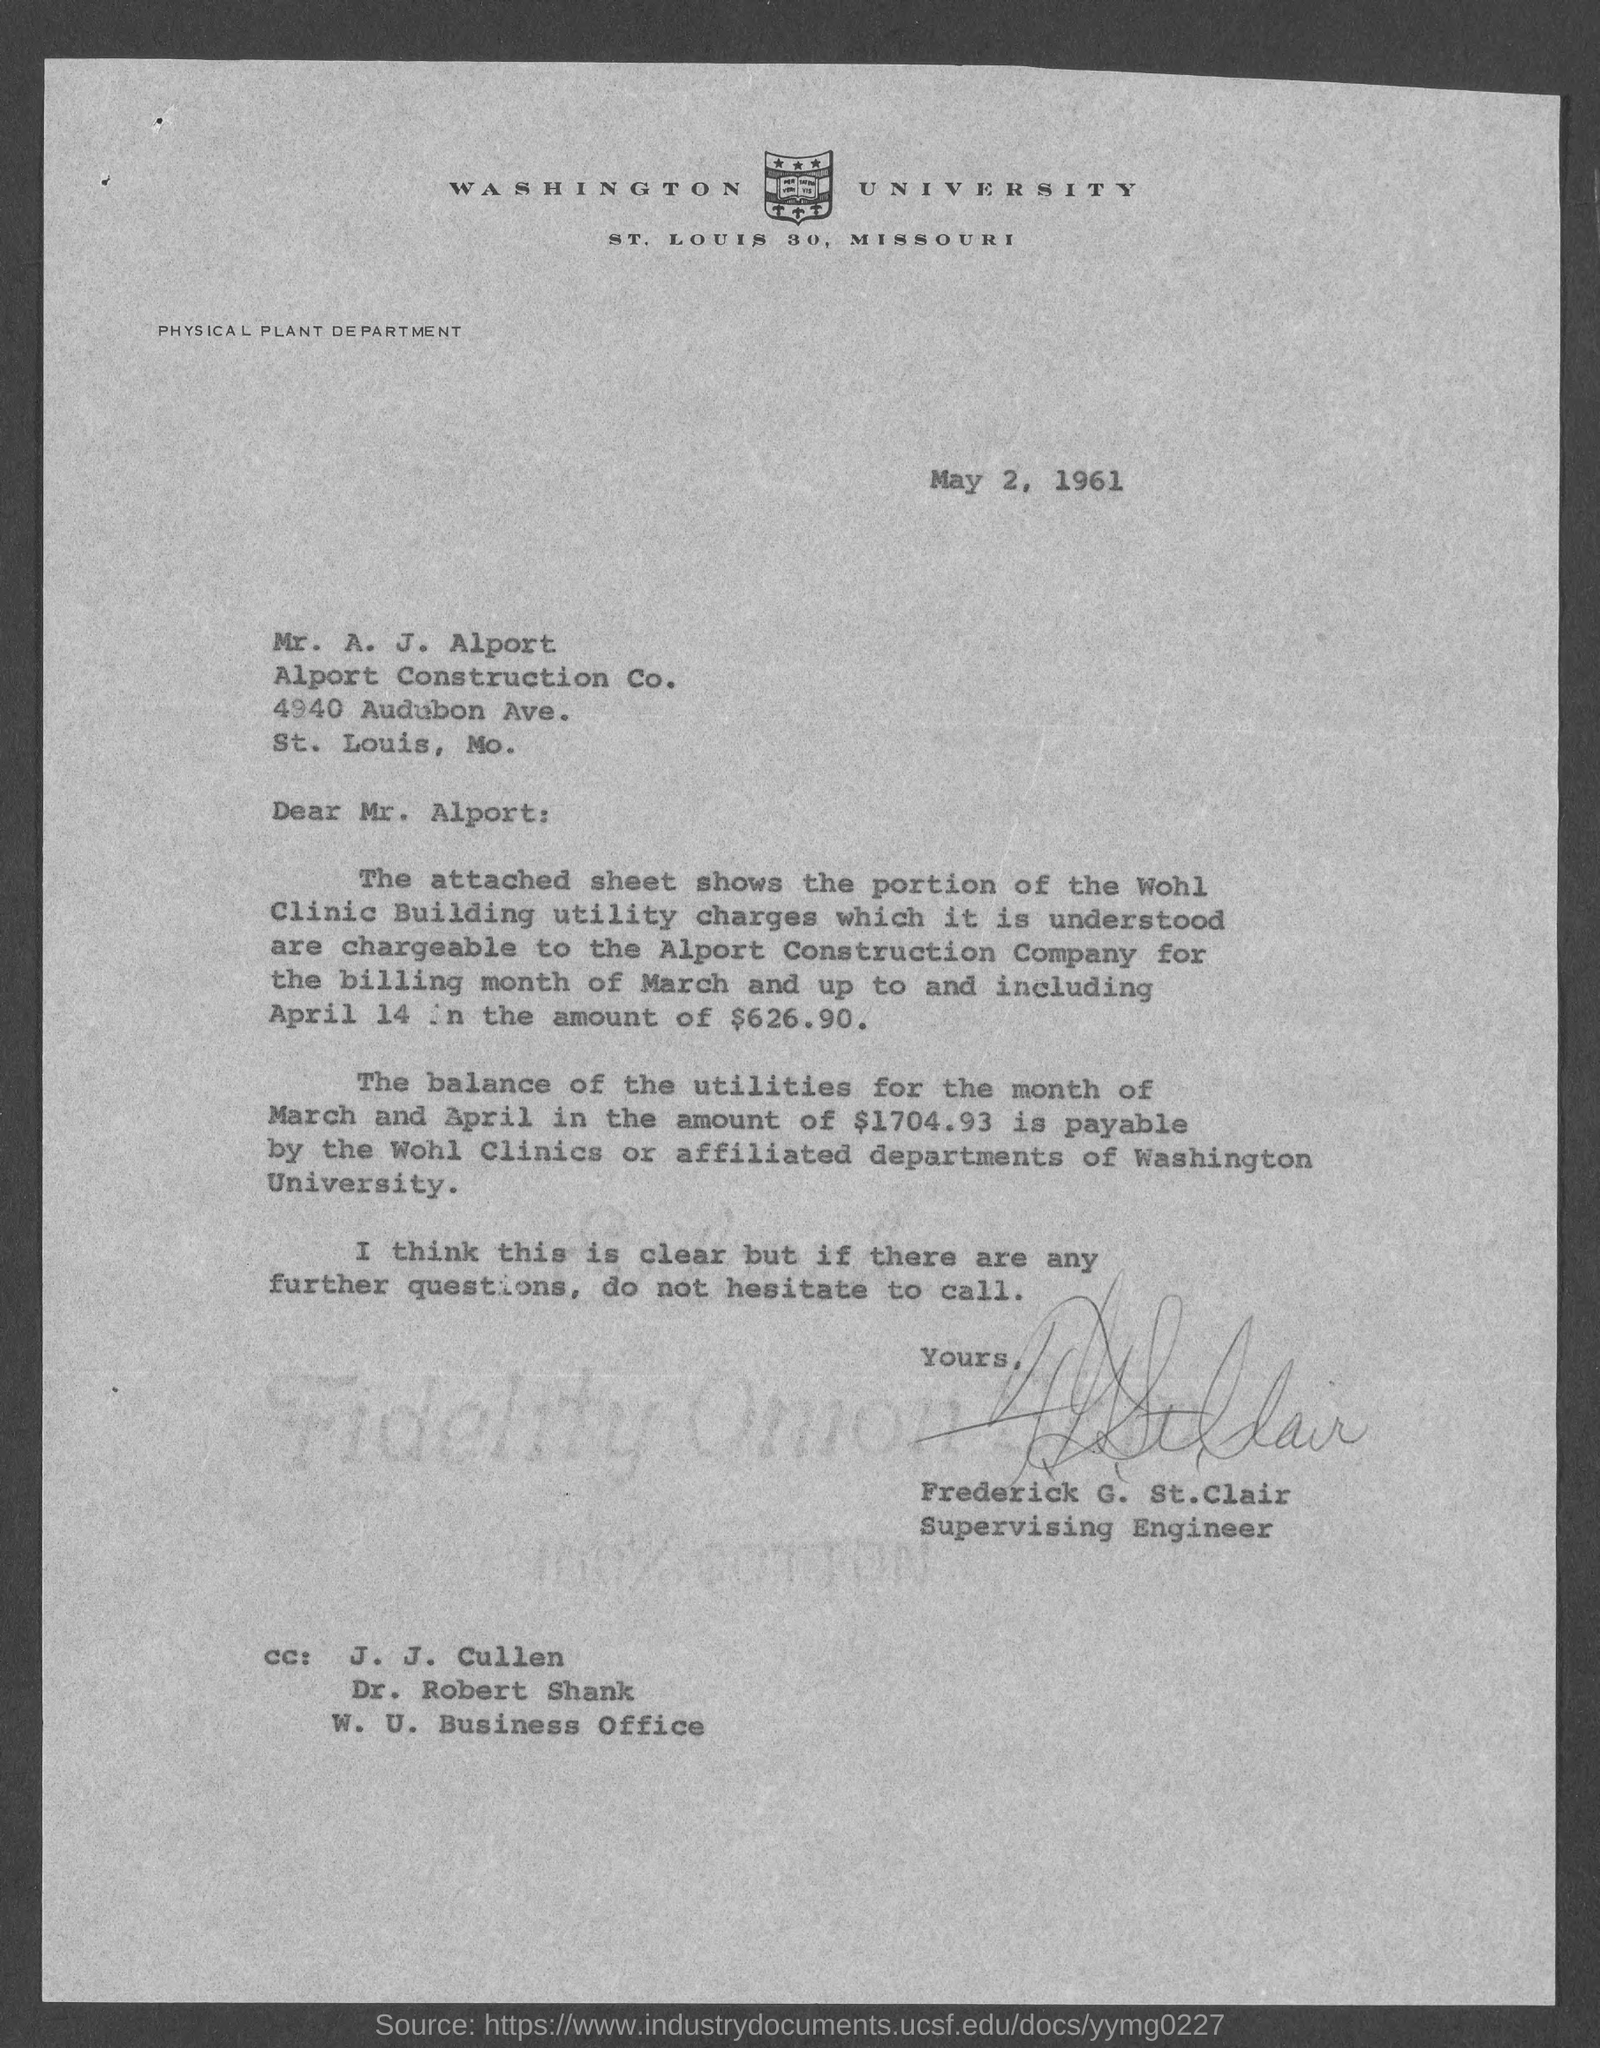Who has signed the letter?
Make the answer very short. Frederick g. st.clair. When is  the letter dated on?
Ensure brevity in your answer.  May 2, 1961. 